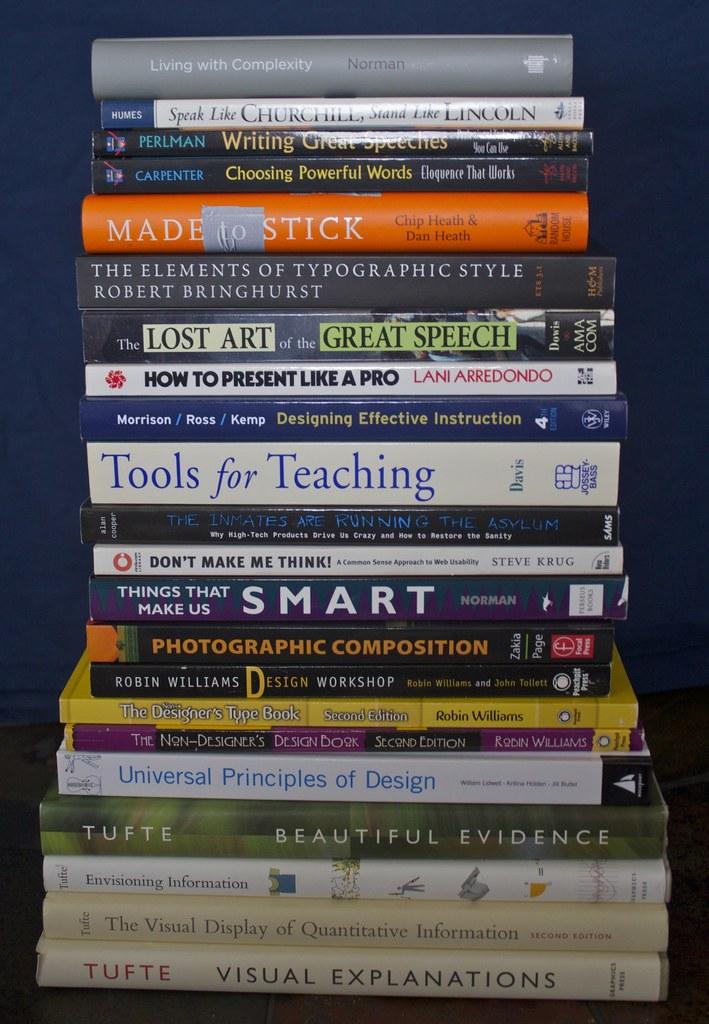Who wrote speak like churchill, stand like lincoln?
Your response must be concise. Humes. What is the title of the bottom book?
Offer a terse response. Visual explanations. 